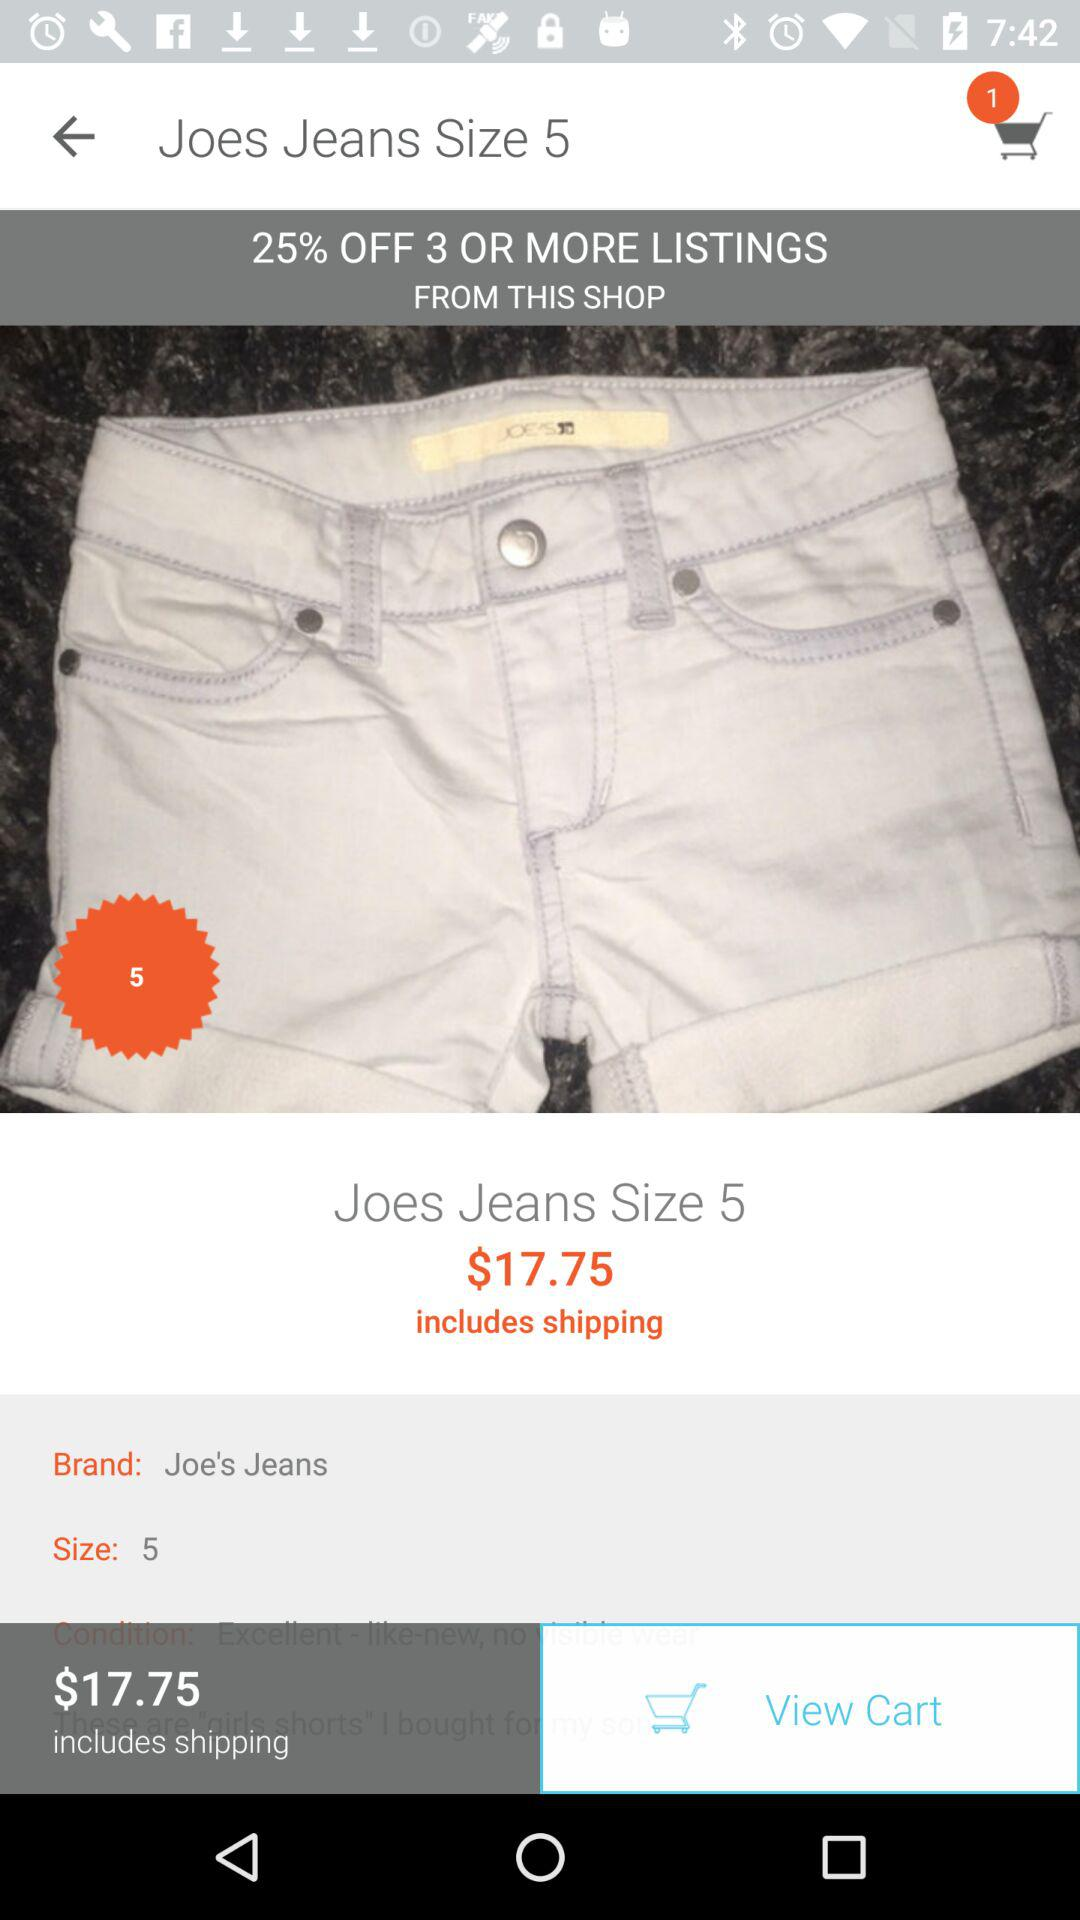What is the price of the item?
Answer the question using a single word or phrase. $17.75 